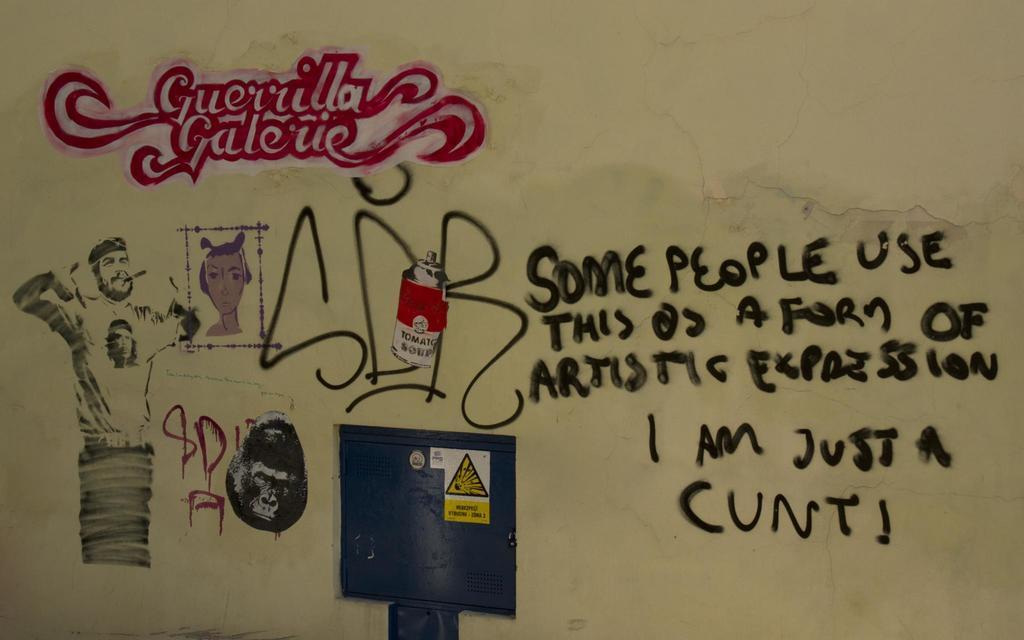Please provide a concise description of this image. In this image we can see drawings and texts written on the wall. There are pictures of a man and an animal on the wall and we can see a locker door. 